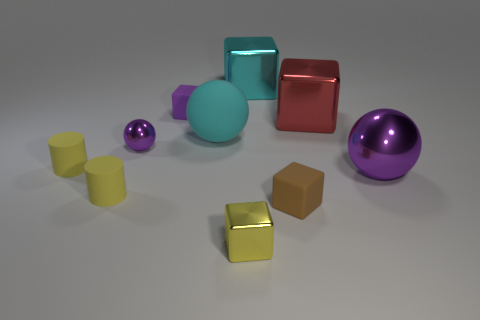There is a metal thing that is the same color as the tiny ball; what size is it?
Your answer should be compact. Large. Are there more yellow cylinders than red matte cylinders?
Provide a short and direct response. Yes. Do the tiny metal block and the tiny ball have the same color?
Make the answer very short. No. What number of things are either cyan blocks or large cyan objects that are behind the red object?
Offer a very short reply. 1. What number of other things are the same shape as the purple rubber thing?
Keep it short and to the point. 4. Is the number of small yellow things on the right side of the tiny purple rubber cube less than the number of yellow rubber cylinders that are to the right of the cyan metallic cube?
Your answer should be compact. No. Is there anything else that is the same material as the yellow cube?
Give a very brief answer. Yes. There is a big cyan thing that is the same material as the purple cube; what shape is it?
Provide a succinct answer. Sphere. Is there anything else of the same color as the tiny shiny cube?
Ensure brevity in your answer.  Yes. There is a small object to the right of the big shiny cube behind the red shiny object; what is its color?
Ensure brevity in your answer.  Brown. 